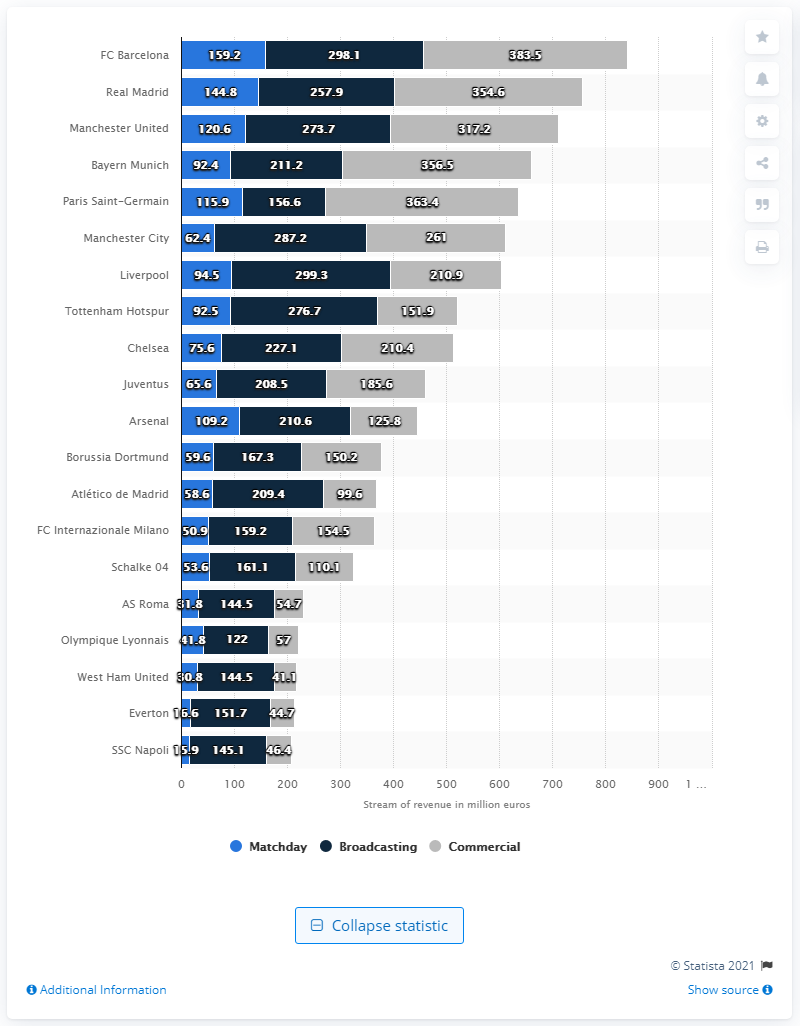Point out several critical features in this image. Real Madrid generated a matchday revenue of 144.8 million euros, making it the Spanish football club that earned the most from this source of revenue. In the 2018/19 season, Real Madrid generated a total of 144.8 million euros in matchday revenues. 